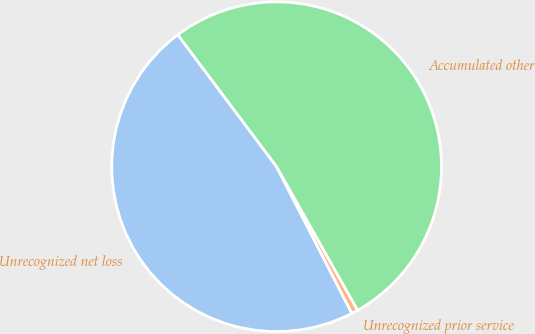Convert chart to OTSL. <chart><loc_0><loc_0><loc_500><loc_500><pie_chart><fcel>Unrecognized net loss<fcel>Unrecognized prior service<fcel>Accumulated other<nl><fcel>47.32%<fcel>0.63%<fcel>52.05%<nl></chart> 